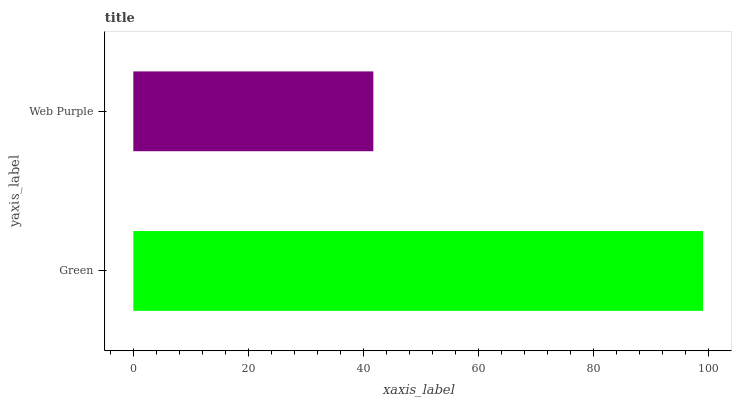Is Web Purple the minimum?
Answer yes or no. Yes. Is Green the maximum?
Answer yes or no. Yes. Is Web Purple the maximum?
Answer yes or no. No. Is Green greater than Web Purple?
Answer yes or no. Yes. Is Web Purple less than Green?
Answer yes or no. Yes. Is Web Purple greater than Green?
Answer yes or no. No. Is Green less than Web Purple?
Answer yes or no. No. Is Green the high median?
Answer yes or no. Yes. Is Web Purple the low median?
Answer yes or no. Yes. Is Web Purple the high median?
Answer yes or no. No. Is Green the low median?
Answer yes or no. No. 